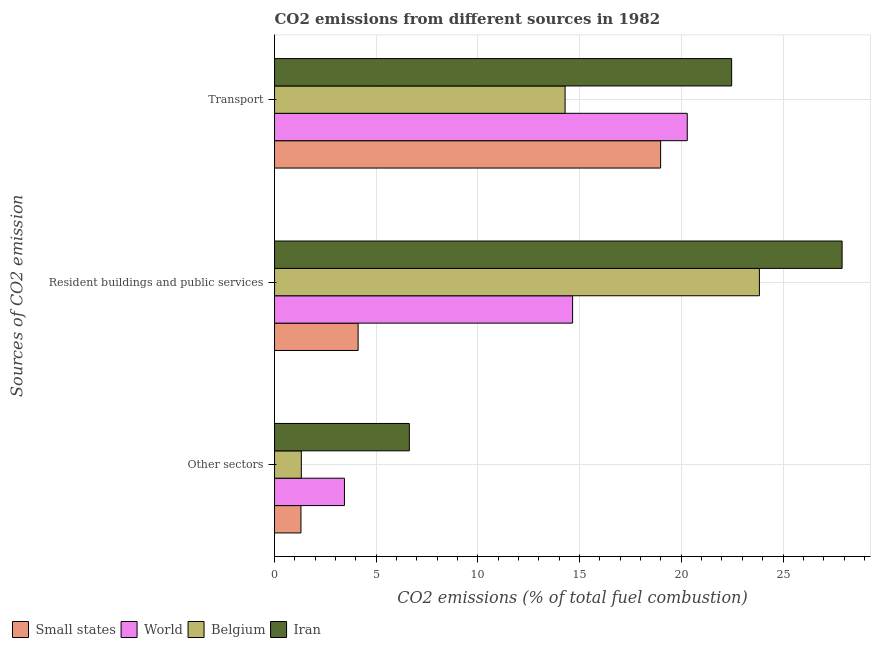How many different coloured bars are there?
Offer a terse response. 4. How many groups of bars are there?
Make the answer very short. 3. How many bars are there on the 1st tick from the top?
Keep it short and to the point. 4. How many bars are there on the 2nd tick from the bottom?
Offer a terse response. 4. What is the label of the 3rd group of bars from the top?
Your response must be concise. Other sectors. What is the percentage of co2 emissions from transport in Belgium?
Provide a short and direct response. 14.29. Across all countries, what is the maximum percentage of co2 emissions from other sectors?
Give a very brief answer. 6.63. Across all countries, what is the minimum percentage of co2 emissions from other sectors?
Your answer should be compact. 1.3. In which country was the percentage of co2 emissions from transport maximum?
Provide a succinct answer. Iran. In which country was the percentage of co2 emissions from transport minimum?
Your answer should be very brief. Belgium. What is the total percentage of co2 emissions from resident buildings and public services in the graph?
Your answer should be compact. 70.51. What is the difference between the percentage of co2 emissions from transport in Iran and that in Small states?
Provide a succinct answer. 3.49. What is the difference between the percentage of co2 emissions from other sectors in World and the percentage of co2 emissions from transport in Belgium?
Give a very brief answer. -10.85. What is the average percentage of co2 emissions from transport per country?
Keep it short and to the point. 19.01. What is the difference between the percentage of co2 emissions from transport and percentage of co2 emissions from resident buildings and public services in World?
Your response must be concise. 5.64. In how many countries, is the percentage of co2 emissions from other sectors greater than 4 %?
Give a very brief answer. 1. What is the ratio of the percentage of co2 emissions from resident buildings and public services in Iran to that in World?
Keep it short and to the point. 1.9. Is the percentage of co2 emissions from resident buildings and public services in Small states less than that in Belgium?
Keep it short and to the point. Yes. Is the difference between the percentage of co2 emissions from other sectors in Small states and Belgium greater than the difference between the percentage of co2 emissions from transport in Small states and Belgium?
Provide a succinct answer. No. What is the difference between the highest and the second highest percentage of co2 emissions from other sectors?
Provide a succinct answer. 3.19. What is the difference between the highest and the lowest percentage of co2 emissions from other sectors?
Make the answer very short. 5.33. In how many countries, is the percentage of co2 emissions from resident buildings and public services greater than the average percentage of co2 emissions from resident buildings and public services taken over all countries?
Your answer should be compact. 2. What does the 1st bar from the bottom in Other sectors represents?
Your response must be concise. Small states. Is it the case that in every country, the sum of the percentage of co2 emissions from other sectors and percentage of co2 emissions from resident buildings and public services is greater than the percentage of co2 emissions from transport?
Your answer should be compact. No. How many bars are there?
Your answer should be compact. 12. Are all the bars in the graph horizontal?
Ensure brevity in your answer.  Yes. What is the difference between two consecutive major ticks on the X-axis?
Keep it short and to the point. 5. Are the values on the major ticks of X-axis written in scientific E-notation?
Provide a succinct answer. No. How are the legend labels stacked?
Keep it short and to the point. Horizontal. What is the title of the graph?
Ensure brevity in your answer.  CO2 emissions from different sources in 1982. What is the label or title of the X-axis?
Your response must be concise. CO2 emissions (% of total fuel combustion). What is the label or title of the Y-axis?
Your answer should be compact. Sources of CO2 emission. What is the CO2 emissions (% of total fuel combustion) in Small states in Other sectors?
Ensure brevity in your answer.  1.3. What is the CO2 emissions (% of total fuel combustion) in World in Other sectors?
Give a very brief answer. 3.44. What is the CO2 emissions (% of total fuel combustion) in Belgium in Other sectors?
Give a very brief answer. 1.32. What is the CO2 emissions (% of total fuel combustion) of Iran in Other sectors?
Make the answer very short. 6.63. What is the CO2 emissions (% of total fuel combustion) of Small states in Resident buildings and public services?
Provide a succinct answer. 4.11. What is the CO2 emissions (% of total fuel combustion) in World in Resident buildings and public services?
Offer a terse response. 14.66. What is the CO2 emissions (% of total fuel combustion) of Belgium in Resident buildings and public services?
Your answer should be compact. 23.84. What is the CO2 emissions (% of total fuel combustion) in Iran in Resident buildings and public services?
Offer a terse response. 27.91. What is the CO2 emissions (% of total fuel combustion) in Small states in Transport?
Make the answer very short. 18.98. What is the CO2 emissions (% of total fuel combustion) in World in Transport?
Your answer should be compact. 20.29. What is the CO2 emissions (% of total fuel combustion) in Belgium in Transport?
Offer a very short reply. 14.29. What is the CO2 emissions (% of total fuel combustion) in Iran in Transport?
Your response must be concise. 22.48. Across all Sources of CO2 emission, what is the maximum CO2 emissions (% of total fuel combustion) of Small states?
Ensure brevity in your answer.  18.98. Across all Sources of CO2 emission, what is the maximum CO2 emissions (% of total fuel combustion) of World?
Provide a succinct answer. 20.29. Across all Sources of CO2 emission, what is the maximum CO2 emissions (% of total fuel combustion) of Belgium?
Give a very brief answer. 23.84. Across all Sources of CO2 emission, what is the maximum CO2 emissions (% of total fuel combustion) in Iran?
Your answer should be compact. 27.91. Across all Sources of CO2 emission, what is the minimum CO2 emissions (% of total fuel combustion) in Small states?
Provide a succinct answer. 1.3. Across all Sources of CO2 emission, what is the minimum CO2 emissions (% of total fuel combustion) of World?
Offer a very short reply. 3.44. Across all Sources of CO2 emission, what is the minimum CO2 emissions (% of total fuel combustion) of Belgium?
Make the answer very short. 1.32. Across all Sources of CO2 emission, what is the minimum CO2 emissions (% of total fuel combustion) of Iran?
Your answer should be compact. 6.63. What is the total CO2 emissions (% of total fuel combustion) in Small states in the graph?
Offer a very short reply. 24.39. What is the total CO2 emissions (% of total fuel combustion) of World in the graph?
Make the answer very short. 38.39. What is the total CO2 emissions (% of total fuel combustion) of Belgium in the graph?
Give a very brief answer. 39.44. What is the total CO2 emissions (% of total fuel combustion) of Iran in the graph?
Make the answer very short. 57.01. What is the difference between the CO2 emissions (% of total fuel combustion) of Small states in Other sectors and that in Resident buildings and public services?
Provide a short and direct response. -2.81. What is the difference between the CO2 emissions (% of total fuel combustion) of World in Other sectors and that in Resident buildings and public services?
Offer a very short reply. -11.22. What is the difference between the CO2 emissions (% of total fuel combustion) of Belgium in Other sectors and that in Resident buildings and public services?
Keep it short and to the point. -22.52. What is the difference between the CO2 emissions (% of total fuel combustion) of Iran in Other sectors and that in Resident buildings and public services?
Ensure brevity in your answer.  -21.28. What is the difference between the CO2 emissions (% of total fuel combustion) in Small states in Other sectors and that in Transport?
Make the answer very short. -17.69. What is the difference between the CO2 emissions (% of total fuel combustion) of World in Other sectors and that in Transport?
Offer a very short reply. -16.86. What is the difference between the CO2 emissions (% of total fuel combustion) of Belgium in Other sectors and that in Transport?
Your answer should be compact. -12.97. What is the difference between the CO2 emissions (% of total fuel combustion) of Iran in Other sectors and that in Transport?
Give a very brief answer. -15.85. What is the difference between the CO2 emissions (% of total fuel combustion) in Small states in Resident buildings and public services and that in Transport?
Your answer should be compact. -14.87. What is the difference between the CO2 emissions (% of total fuel combustion) of World in Resident buildings and public services and that in Transport?
Keep it short and to the point. -5.64. What is the difference between the CO2 emissions (% of total fuel combustion) in Belgium in Resident buildings and public services and that in Transport?
Make the answer very short. 9.55. What is the difference between the CO2 emissions (% of total fuel combustion) in Iran in Resident buildings and public services and that in Transport?
Offer a very short reply. 5.43. What is the difference between the CO2 emissions (% of total fuel combustion) of Small states in Other sectors and the CO2 emissions (% of total fuel combustion) of World in Resident buildings and public services?
Offer a very short reply. -13.36. What is the difference between the CO2 emissions (% of total fuel combustion) of Small states in Other sectors and the CO2 emissions (% of total fuel combustion) of Belgium in Resident buildings and public services?
Your answer should be very brief. -22.54. What is the difference between the CO2 emissions (% of total fuel combustion) in Small states in Other sectors and the CO2 emissions (% of total fuel combustion) in Iran in Resident buildings and public services?
Your answer should be compact. -26.61. What is the difference between the CO2 emissions (% of total fuel combustion) in World in Other sectors and the CO2 emissions (% of total fuel combustion) in Belgium in Resident buildings and public services?
Give a very brief answer. -20.4. What is the difference between the CO2 emissions (% of total fuel combustion) of World in Other sectors and the CO2 emissions (% of total fuel combustion) of Iran in Resident buildings and public services?
Your answer should be compact. -24.47. What is the difference between the CO2 emissions (% of total fuel combustion) in Belgium in Other sectors and the CO2 emissions (% of total fuel combustion) in Iran in Resident buildings and public services?
Make the answer very short. -26.59. What is the difference between the CO2 emissions (% of total fuel combustion) of Small states in Other sectors and the CO2 emissions (% of total fuel combustion) of World in Transport?
Give a very brief answer. -19. What is the difference between the CO2 emissions (% of total fuel combustion) in Small states in Other sectors and the CO2 emissions (% of total fuel combustion) in Belgium in Transport?
Keep it short and to the point. -12.99. What is the difference between the CO2 emissions (% of total fuel combustion) of Small states in Other sectors and the CO2 emissions (% of total fuel combustion) of Iran in Transport?
Your answer should be very brief. -21.18. What is the difference between the CO2 emissions (% of total fuel combustion) of World in Other sectors and the CO2 emissions (% of total fuel combustion) of Belgium in Transport?
Your answer should be compact. -10.85. What is the difference between the CO2 emissions (% of total fuel combustion) of World in Other sectors and the CO2 emissions (% of total fuel combustion) of Iran in Transport?
Provide a short and direct response. -19.04. What is the difference between the CO2 emissions (% of total fuel combustion) in Belgium in Other sectors and the CO2 emissions (% of total fuel combustion) in Iran in Transport?
Offer a very short reply. -21.16. What is the difference between the CO2 emissions (% of total fuel combustion) in Small states in Resident buildings and public services and the CO2 emissions (% of total fuel combustion) in World in Transport?
Give a very brief answer. -16.18. What is the difference between the CO2 emissions (% of total fuel combustion) in Small states in Resident buildings and public services and the CO2 emissions (% of total fuel combustion) in Belgium in Transport?
Ensure brevity in your answer.  -10.18. What is the difference between the CO2 emissions (% of total fuel combustion) of Small states in Resident buildings and public services and the CO2 emissions (% of total fuel combustion) of Iran in Transport?
Give a very brief answer. -18.37. What is the difference between the CO2 emissions (% of total fuel combustion) in World in Resident buildings and public services and the CO2 emissions (% of total fuel combustion) in Belgium in Transport?
Your response must be concise. 0.37. What is the difference between the CO2 emissions (% of total fuel combustion) in World in Resident buildings and public services and the CO2 emissions (% of total fuel combustion) in Iran in Transport?
Your answer should be very brief. -7.82. What is the difference between the CO2 emissions (% of total fuel combustion) in Belgium in Resident buildings and public services and the CO2 emissions (% of total fuel combustion) in Iran in Transport?
Keep it short and to the point. 1.36. What is the average CO2 emissions (% of total fuel combustion) in Small states per Sources of CO2 emission?
Ensure brevity in your answer.  8.13. What is the average CO2 emissions (% of total fuel combustion) in World per Sources of CO2 emission?
Your response must be concise. 12.8. What is the average CO2 emissions (% of total fuel combustion) in Belgium per Sources of CO2 emission?
Make the answer very short. 13.15. What is the average CO2 emissions (% of total fuel combustion) of Iran per Sources of CO2 emission?
Your answer should be very brief. 19. What is the difference between the CO2 emissions (% of total fuel combustion) in Small states and CO2 emissions (% of total fuel combustion) in World in Other sectors?
Make the answer very short. -2.14. What is the difference between the CO2 emissions (% of total fuel combustion) of Small states and CO2 emissions (% of total fuel combustion) of Belgium in Other sectors?
Provide a succinct answer. -0.02. What is the difference between the CO2 emissions (% of total fuel combustion) of Small states and CO2 emissions (% of total fuel combustion) of Iran in Other sectors?
Your response must be concise. -5.33. What is the difference between the CO2 emissions (% of total fuel combustion) in World and CO2 emissions (% of total fuel combustion) in Belgium in Other sectors?
Provide a short and direct response. 2.12. What is the difference between the CO2 emissions (% of total fuel combustion) of World and CO2 emissions (% of total fuel combustion) of Iran in Other sectors?
Offer a very short reply. -3.19. What is the difference between the CO2 emissions (% of total fuel combustion) of Belgium and CO2 emissions (% of total fuel combustion) of Iran in Other sectors?
Provide a succinct answer. -5.31. What is the difference between the CO2 emissions (% of total fuel combustion) in Small states and CO2 emissions (% of total fuel combustion) in World in Resident buildings and public services?
Your response must be concise. -10.55. What is the difference between the CO2 emissions (% of total fuel combustion) of Small states and CO2 emissions (% of total fuel combustion) of Belgium in Resident buildings and public services?
Offer a very short reply. -19.73. What is the difference between the CO2 emissions (% of total fuel combustion) in Small states and CO2 emissions (% of total fuel combustion) in Iran in Resident buildings and public services?
Your response must be concise. -23.8. What is the difference between the CO2 emissions (% of total fuel combustion) of World and CO2 emissions (% of total fuel combustion) of Belgium in Resident buildings and public services?
Keep it short and to the point. -9.18. What is the difference between the CO2 emissions (% of total fuel combustion) in World and CO2 emissions (% of total fuel combustion) in Iran in Resident buildings and public services?
Offer a very short reply. -13.25. What is the difference between the CO2 emissions (% of total fuel combustion) in Belgium and CO2 emissions (% of total fuel combustion) in Iran in Resident buildings and public services?
Offer a terse response. -4.07. What is the difference between the CO2 emissions (% of total fuel combustion) in Small states and CO2 emissions (% of total fuel combustion) in World in Transport?
Give a very brief answer. -1.31. What is the difference between the CO2 emissions (% of total fuel combustion) in Small states and CO2 emissions (% of total fuel combustion) in Belgium in Transport?
Keep it short and to the point. 4.7. What is the difference between the CO2 emissions (% of total fuel combustion) in Small states and CO2 emissions (% of total fuel combustion) in Iran in Transport?
Your response must be concise. -3.49. What is the difference between the CO2 emissions (% of total fuel combustion) of World and CO2 emissions (% of total fuel combustion) of Belgium in Transport?
Offer a very short reply. 6.01. What is the difference between the CO2 emissions (% of total fuel combustion) in World and CO2 emissions (% of total fuel combustion) in Iran in Transport?
Give a very brief answer. -2.18. What is the difference between the CO2 emissions (% of total fuel combustion) of Belgium and CO2 emissions (% of total fuel combustion) of Iran in Transport?
Provide a short and direct response. -8.19. What is the ratio of the CO2 emissions (% of total fuel combustion) of Small states in Other sectors to that in Resident buildings and public services?
Your answer should be compact. 0.32. What is the ratio of the CO2 emissions (% of total fuel combustion) in World in Other sectors to that in Resident buildings and public services?
Make the answer very short. 0.23. What is the ratio of the CO2 emissions (% of total fuel combustion) of Belgium in Other sectors to that in Resident buildings and public services?
Offer a very short reply. 0.06. What is the ratio of the CO2 emissions (% of total fuel combustion) in Iran in Other sectors to that in Resident buildings and public services?
Provide a succinct answer. 0.24. What is the ratio of the CO2 emissions (% of total fuel combustion) in Small states in Other sectors to that in Transport?
Make the answer very short. 0.07. What is the ratio of the CO2 emissions (% of total fuel combustion) in World in Other sectors to that in Transport?
Your answer should be compact. 0.17. What is the ratio of the CO2 emissions (% of total fuel combustion) in Belgium in Other sectors to that in Transport?
Offer a very short reply. 0.09. What is the ratio of the CO2 emissions (% of total fuel combustion) in Iran in Other sectors to that in Transport?
Provide a short and direct response. 0.29. What is the ratio of the CO2 emissions (% of total fuel combustion) of Small states in Resident buildings and public services to that in Transport?
Your answer should be compact. 0.22. What is the ratio of the CO2 emissions (% of total fuel combustion) of World in Resident buildings and public services to that in Transport?
Offer a very short reply. 0.72. What is the ratio of the CO2 emissions (% of total fuel combustion) of Belgium in Resident buildings and public services to that in Transport?
Offer a terse response. 1.67. What is the ratio of the CO2 emissions (% of total fuel combustion) in Iran in Resident buildings and public services to that in Transport?
Provide a short and direct response. 1.24. What is the difference between the highest and the second highest CO2 emissions (% of total fuel combustion) of Small states?
Offer a very short reply. 14.87. What is the difference between the highest and the second highest CO2 emissions (% of total fuel combustion) in World?
Provide a short and direct response. 5.64. What is the difference between the highest and the second highest CO2 emissions (% of total fuel combustion) in Belgium?
Provide a short and direct response. 9.55. What is the difference between the highest and the second highest CO2 emissions (% of total fuel combustion) of Iran?
Your answer should be compact. 5.43. What is the difference between the highest and the lowest CO2 emissions (% of total fuel combustion) in Small states?
Offer a very short reply. 17.69. What is the difference between the highest and the lowest CO2 emissions (% of total fuel combustion) in World?
Ensure brevity in your answer.  16.86. What is the difference between the highest and the lowest CO2 emissions (% of total fuel combustion) in Belgium?
Provide a short and direct response. 22.52. What is the difference between the highest and the lowest CO2 emissions (% of total fuel combustion) of Iran?
Provide a succinct answer. 21.28. 